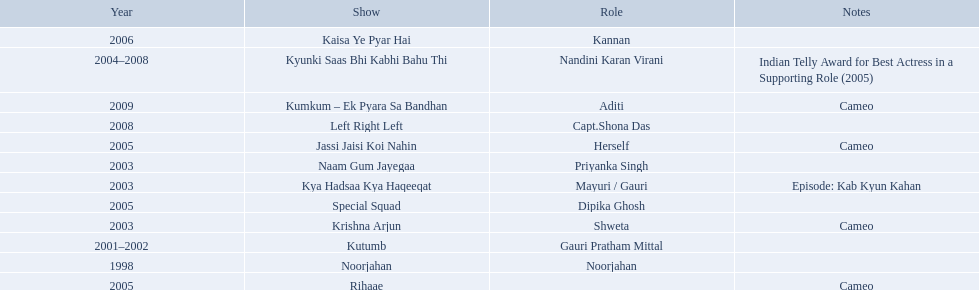What role  was played for the latest show Cameo. Who played the last cameo before ? Jassi Jaisi Koi Nahin. 